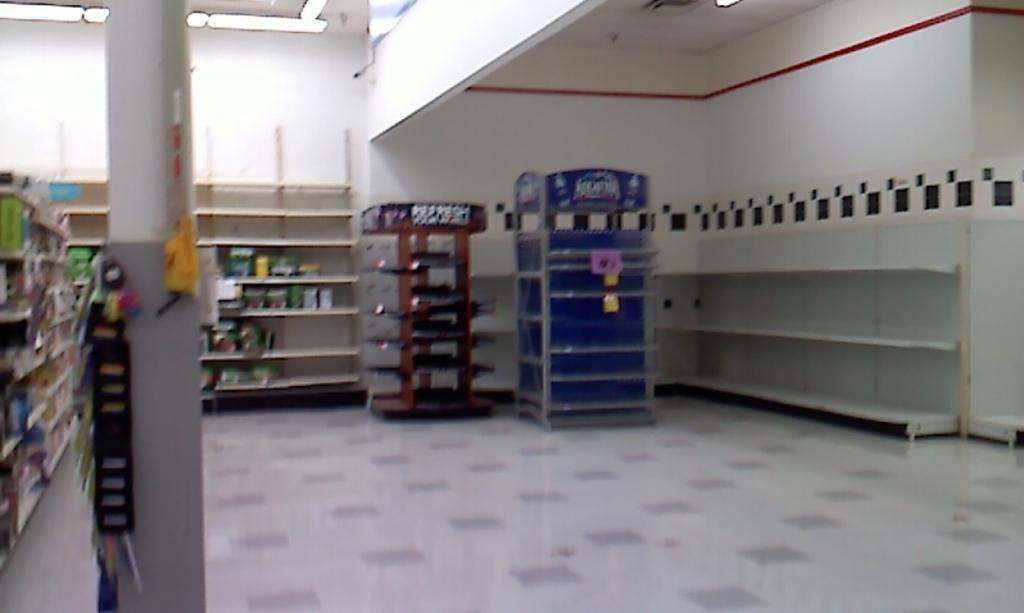Provide a one-sentence caption for the provided image. A large room has a blue cart in it that is filled with Aquafina. 